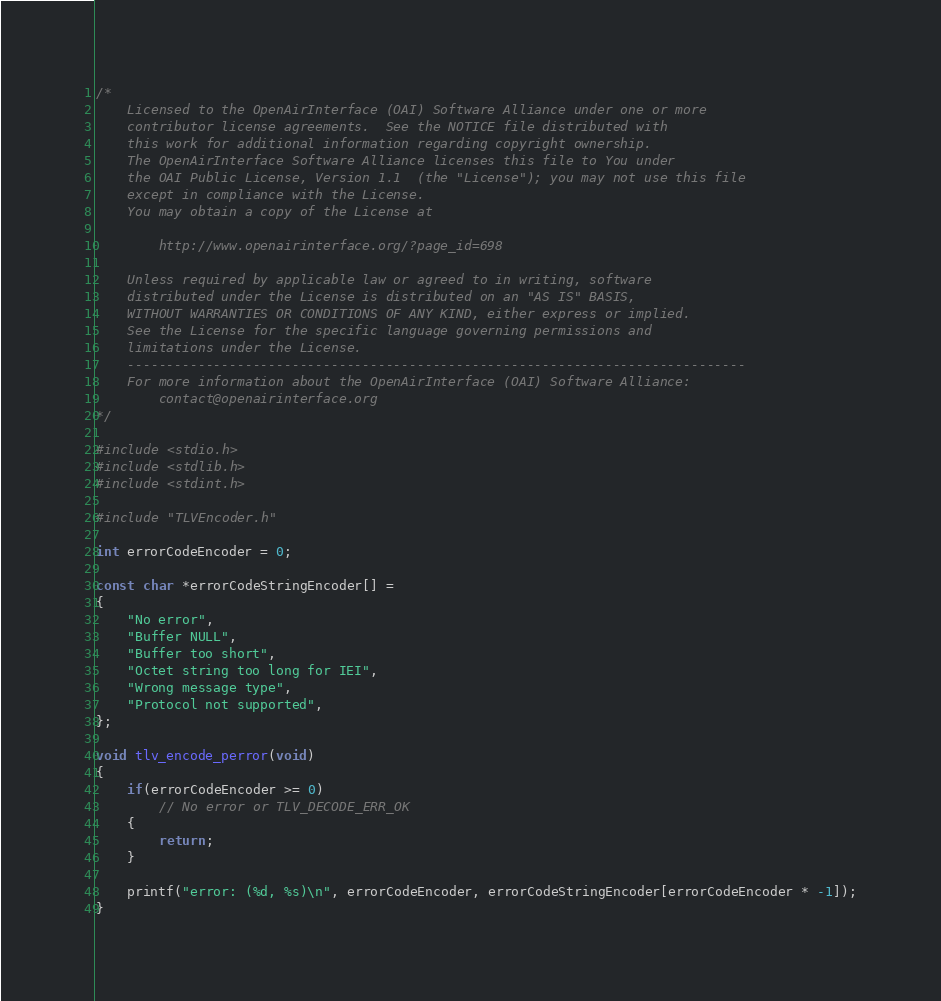<code> <loc_0><loc_0><loc_500><loc_500><_C_>/*
    Licensed to the OpenAirInterface (OAI) Software Alliance under one or more
    contributor license agreements.  See the NOTICE file distributed with
    this work for additional information regarding copyright ownership.
    The OpenAirInterface Software Alliance licenses this file to You under
    the OAI Public License, Version 1.1  (the "License"); you may not use this file
    except in compliance with the License.
    You may obtain a copy of the License at

        http://www.openairinterface.org/?page_id=698

    Unless required by applicable law or agreed to in writing, software
    distributed under the License is distributed on an "AS IS" BASIS,
    WITHOUT WARRANTIES OR CONDITIONS OF ANY KIND, either express or implied.
    See the License for the specific language governing permissions and
    limitations under the License.
    -------------------------------------------------------------------------------
    For more information about the OpenAirInterface (OAI) Software Alliance:
        contact@openairinterface.org
*/

#include <stdio.h>
#include <stdlib.h>
#include <stdint.h>

#include "TLVEncoder.h"

int errorCodeEncoder = 0;

const char *errorCodeStringEncoder[] =
{
    "No error",
    "Buffer NULL",
    "Buffer too short",
    "Octet string too long for IEI",
    "Wrong message type",
    "Protocol not supported",
};

void tlv_encode_perror(void)
{
    if(errorCodeEncoder >= 0)
        // No error or TLV_DECODE_ERR_OK
    {
        return;
    }

    printf("error: (%d, %s)\n", errorCodeEncoder, errorCodeStringEncoder[errorCodeEncoder * -1]);
}

</code> 